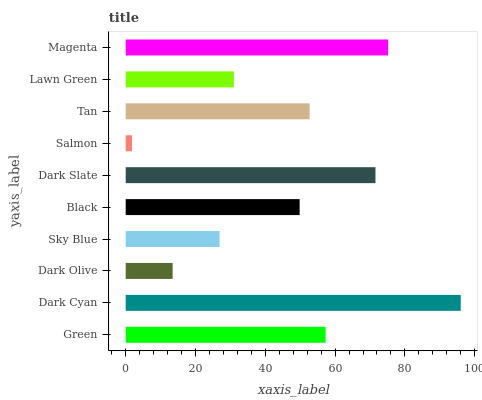Is Salmon the minimum?
Answer yes or no. Yes. Is Dark Cyan the maximum?
Answer yes or no. Yes. Is Dark Olive the minimum?
Answer yes or no. No. Is Dark Olive the maximum?
Answer yes or no. No. Is Dark Cyan greater than Dark Olive?
Answer yes or no. Yes. Is Dark Olive less than Dark Cyan?
Answer yes or no. Yes. Is Dark Olive greater than Dark Cyan?
Answer yes or no. No. Is Dark Cyan less than Dark Olive?
Answer yes or no. No. Is Tan the high median?
Answer yes or no. Yes. Is Black the low median?
Answer yes or no. Yes. Is Salmon the high median?
Answer yes or no. No. Is Dark Cyan the low median?
Answer yes or no. No. 